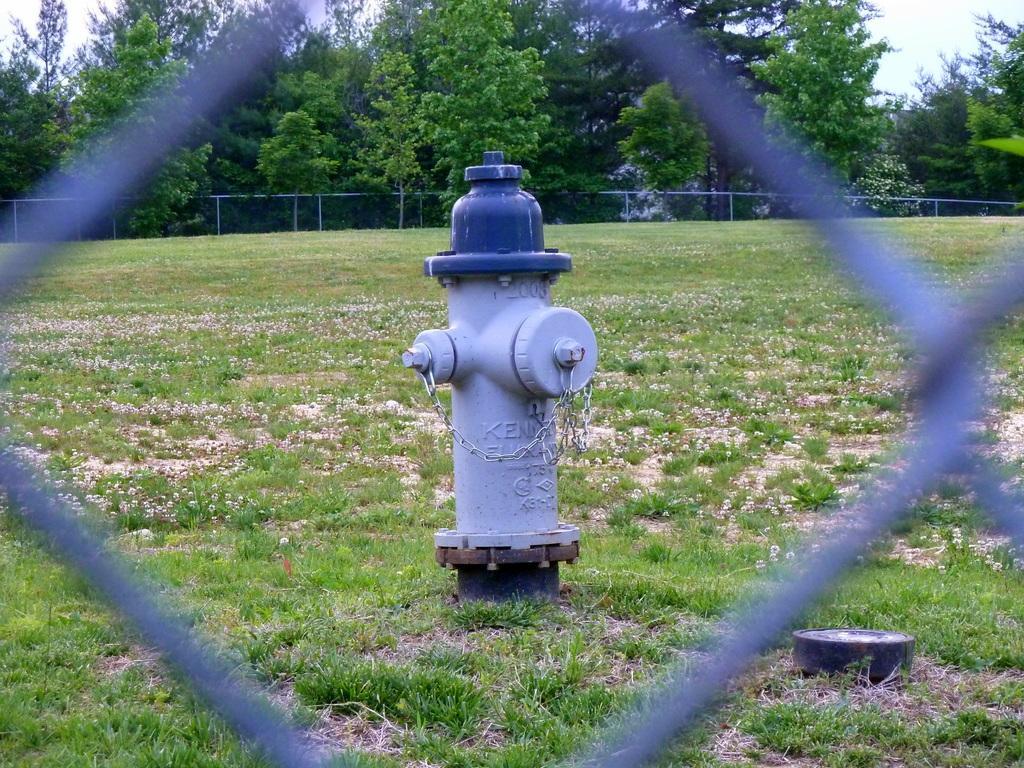Can you describe this image briefly? In this image in the center there is one fire extinguisher, and in the foreground there is a fence. At the bottom there is grass, in the background there is a net and some trees. 